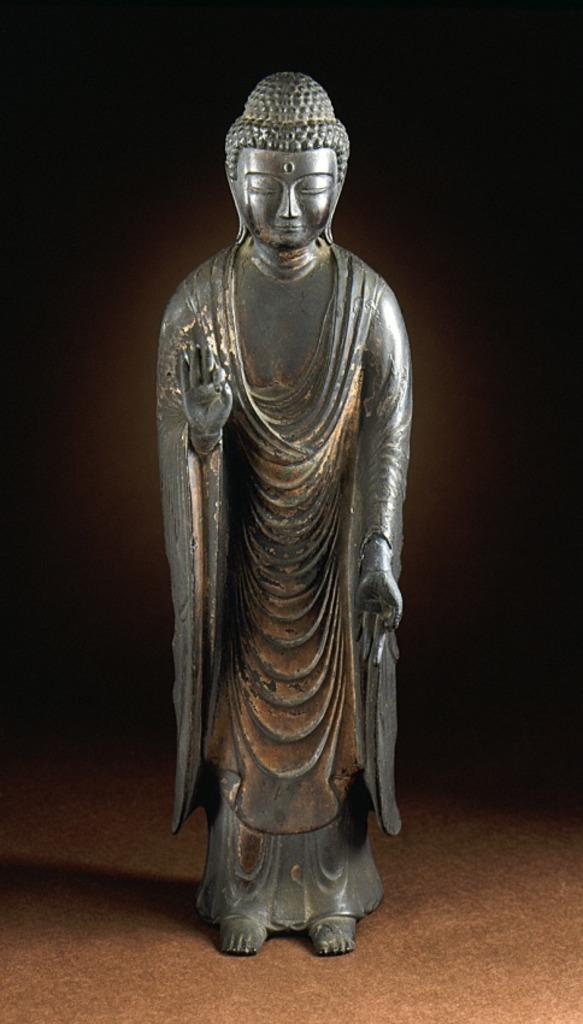Please provide a concise description of this image. This picture is looking like a picture of metal statue of Gautama Buddha with a dark background and kept on floor. 